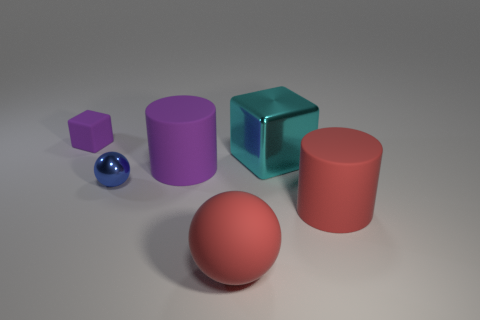Add 2 tiny purple matte objects. How many objects exist? 8 Subtract all cylinders. How many objects are left? 4 Subtract 0 brown balls. How many objects are left? 6 Subtract all big purple rubber objects. Subtract all blue matte spheres. How many objects are left? 5 Add 2 small purple things. How many small purple things are left? 3 Add 5 big red matte cylinders. How many big red matte cylinders exist? 6 